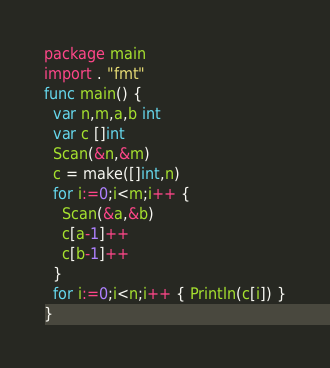Convert code to text. <code><loc_0><loc_0><loc_500><loc_500><_Go_>package main
import . "fmt"
func main() {
  var n,m,a,b int
  var c []int
  Scan(&n,&m)
  c = make([]int,n)
  for i:=0;i<m;i++ {
    Scan(&a,&b)
    c[a-1]++
    c[b-1]++
  }
  for i:=0;i<n;i++ { Println(c[i]) }
}</code> 